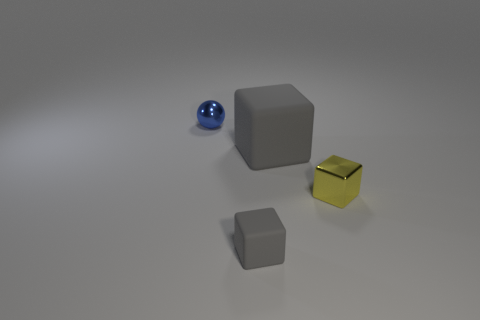Add 4 tiny red cubes. How many objects exist? 8 Subtract all spheres. How many objects are left? 3 Subtract all red metallic cubes. Subtract all small metallic balls. How many objects are left? 3 Add 4 metal balls. How many metal balls are left? 5 Add 3 brown shiny objects. How many brown shiny objects exist? 3 Subtract 0 gray spheres. How many objects are left? 4 